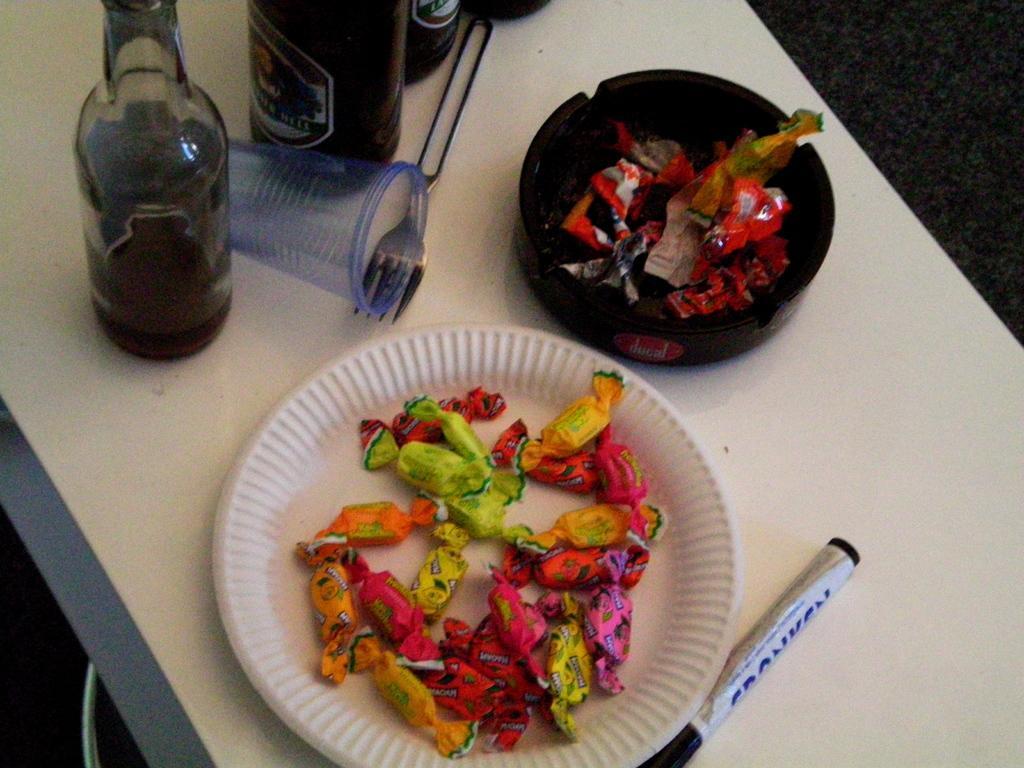How would you summarize this image in a sentence or two? Some chocolates on plate,a marker,a fork,few disposable glasses and some wine bottles are on a table. 